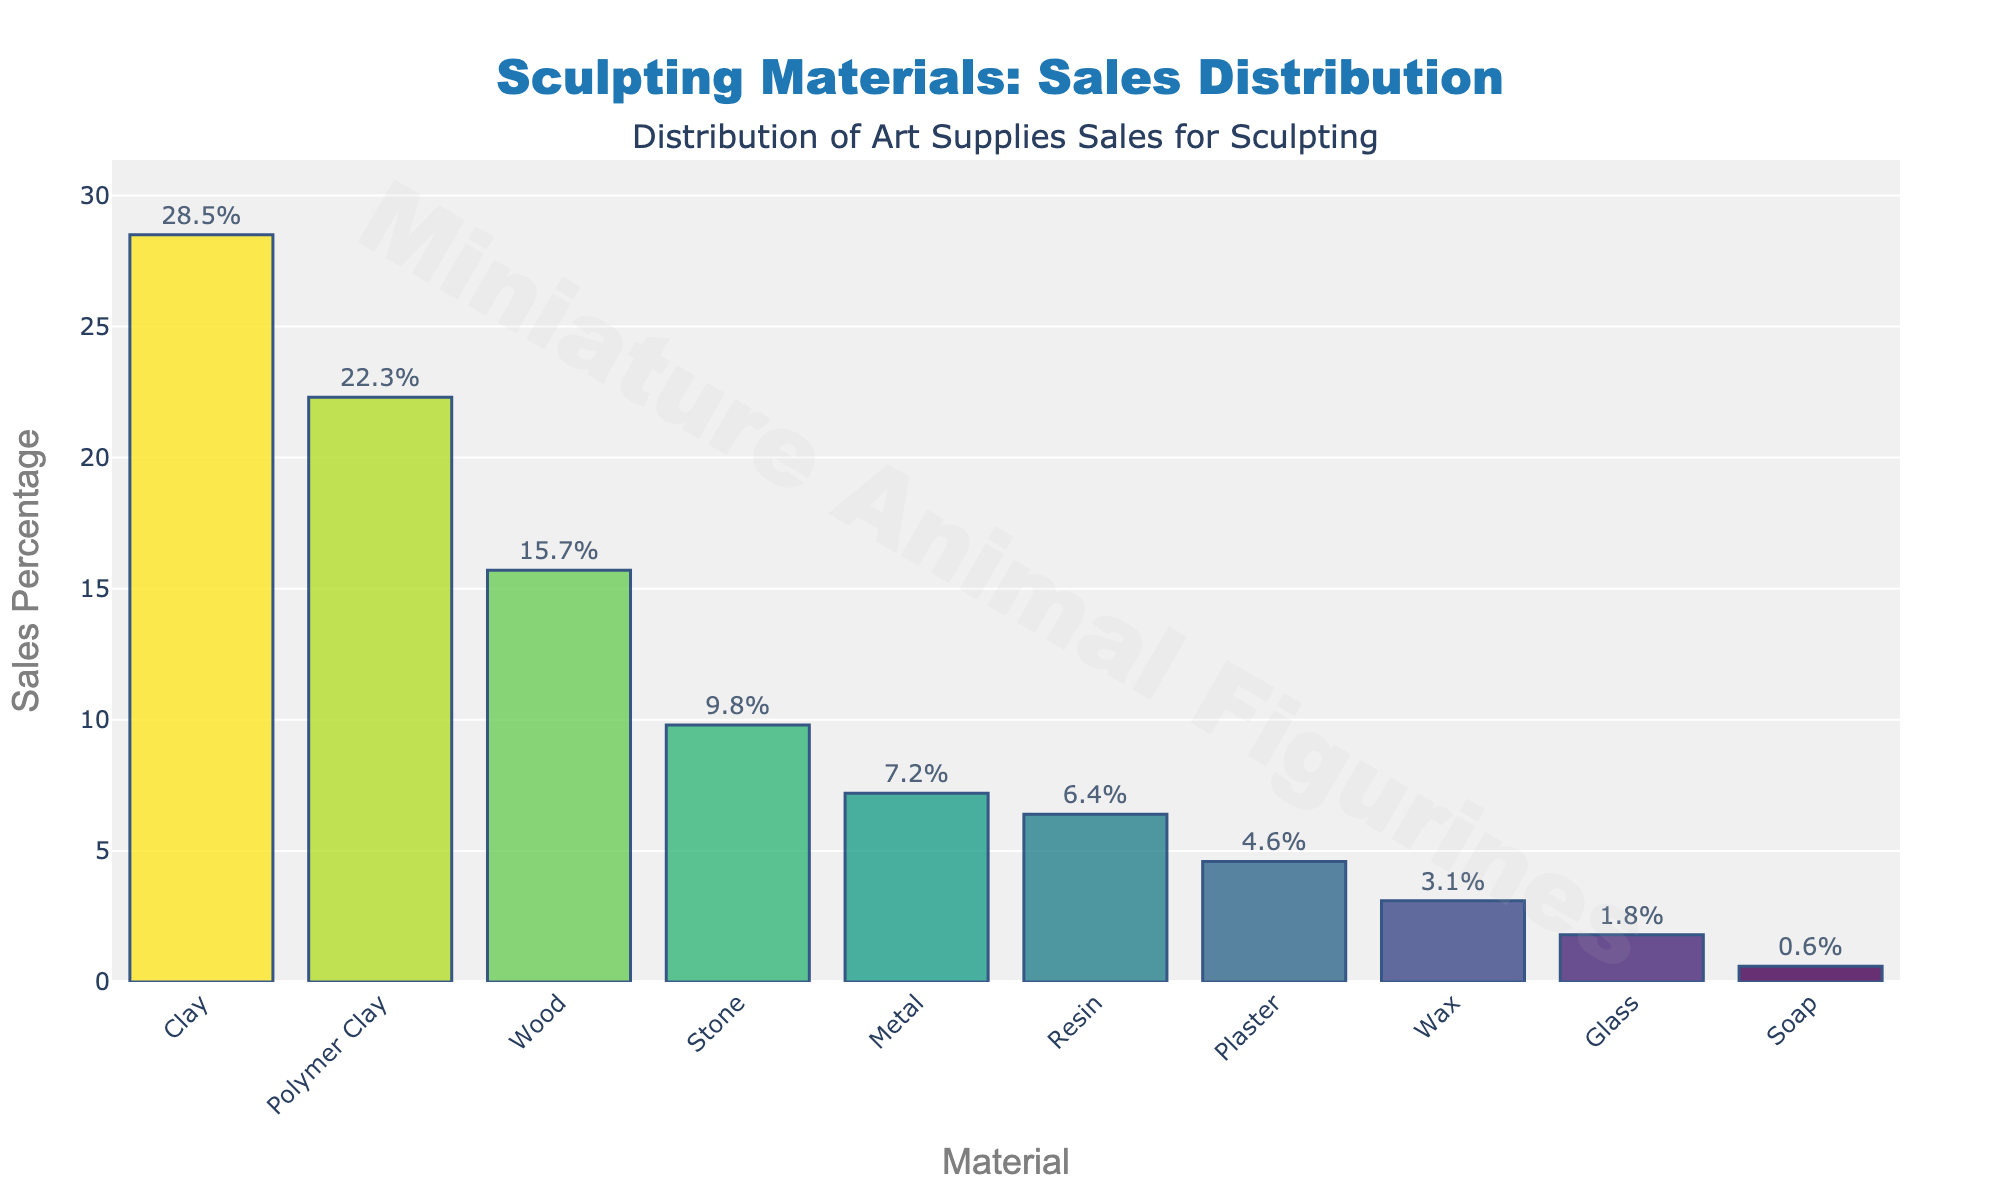What's the material with the highest sales percentage? Look at the bar with the greatest height. The highest bar corresponds to Clay with 28.5%.
Answer: Clay Which material has the lowest sales percentage? Observe the shortest bar in the chart. The lowest bar corresponds to Soap with 0.6%.
Answer: Soap What is the combined sales percentage for Clay and Polymer Clay? Add the sales percentages of Clay and Polymer Clay. Clay has 28.5% and Polymer Clay has 22.3%, so 28.5% + 22.3% = 50.8%.
Answer: 50.8% How much higher is the sales percentage of Wood compared to Stone? Subtract the sales percentage of Stone from that of Wood. Wood's sales percentage is 15.7% and Stone's is 9.8%, so 15.7% - 9.8% = 5.9%.
Answer: 5.9% Rank the materials in decreasing order of sales percentage. Sort the materials by their sales percentages from highest to lowest.
Answer: Clay, Polymer Clay, Wood, Stone, Metal, Resin, Plaster, Wax, Glass, Soap What's the average sales percentage of the top three materials? Add the sales percentages of the top three materials (Clay, Polymer Clay, and Wood) and divide by 3. (28.5 + 22.3 + 15.7)/3 = 22.17%.
Answer: 22.17% Which two materials have similar sales percentages? Look for bars that have nearly the same height. Polymer Clay (22.3%) and Wood (15.7%) are not close. Similarly, Resin (6.4%) and Plaster (4.6%).
Answer: Resin and Plaster Describe the color pattern of the bars. The colors of the bars follow the Viridis color palette from dark purple for the highest percentage to light green for the lowest, transitioning smoothly.
Answer: Viridis palette What is the difference in sales percentage between Metal and Resin? Subtract the sales percentage of Resin from that of Metal. Metal has 7.2% and Resin has 6.4%, so 7.2% - 6.4% = 0.8%.
Answer: 0.8% How many materials have a sales percentage greater than 10%? Count the bars with a height representing a sales percentage above 10%. These materials are Clay (28.5%), Polymer Clay (22.3%), and Wood (15.7%).
Answer: 3 